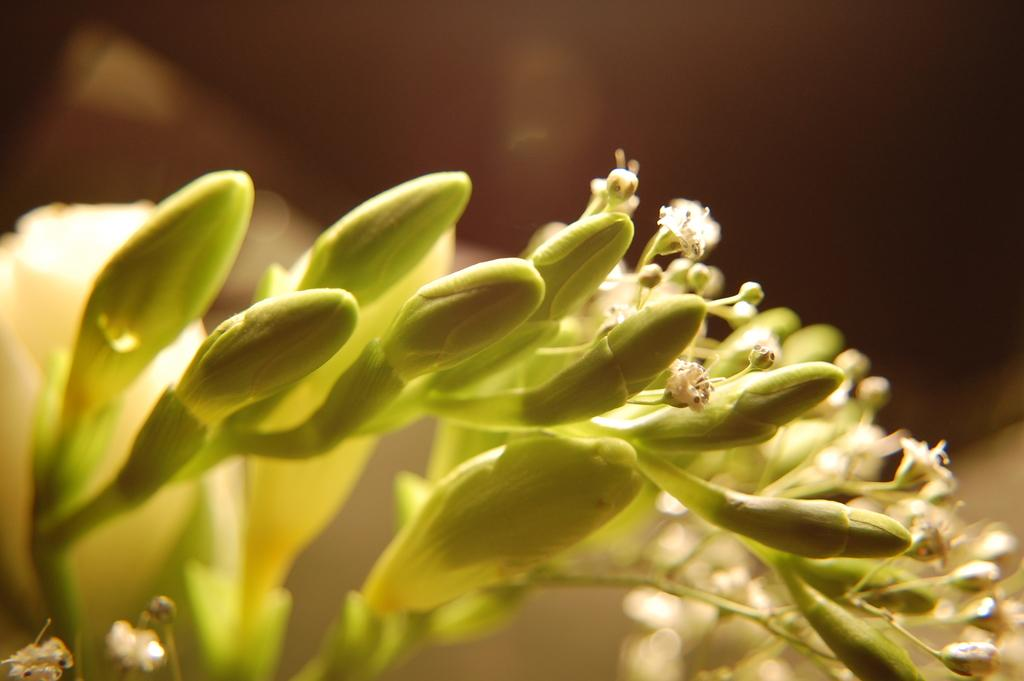What type of plants are visible in the image? There are flowering plants in the image. Can you describe the time of day or night in the image? The image appears to be taken during the night, as indicated by the dark color. How many books are stacked on the sweater in the image? There are no books or sweaters present in the image; it features flowering plants during the night. 